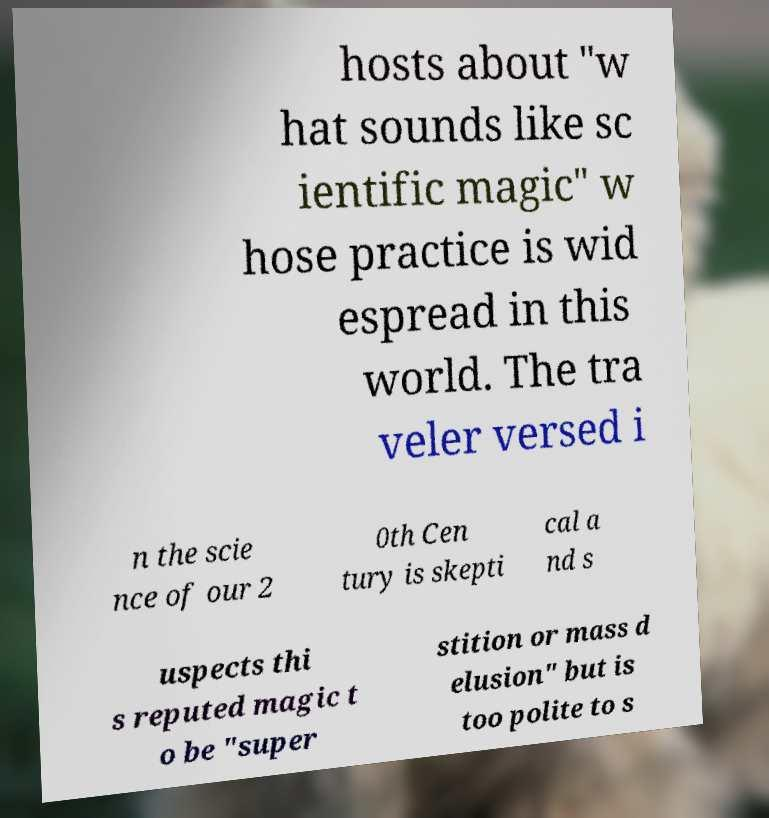Please identify and transcribe the text found in this image. hosts about "w hat sounds like sc ientific magic" w hose practice is wid espread in this world. The tra veler versed i n the scie nce of our 2 0th Cen tury is skepti cal a nd s uspects thi s reputed magic t o be "super stition or mass d elusion" but is too polite to s 